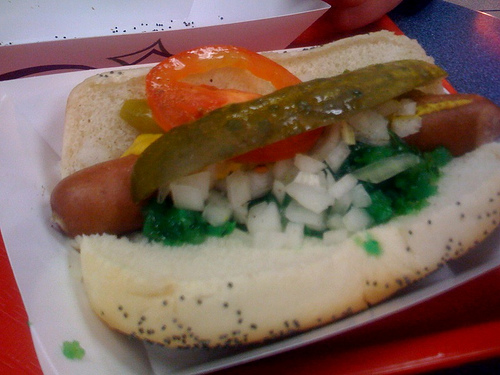<image>
Is the bun on the tray? Yes. Looking at the image, I can see the bun is positioned on top of the tray, with the tray providing support. 